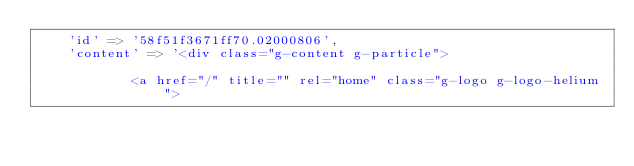<code> <loc_0><loc_0><loc_500><loc_500><_PHP_>    'id' => '58f51f3671ff70.02000806',
    'content' => '<div class="g-content g-particle">
                                                
            <a href="/" title="" rel="home" class="g-logo g-logo-helium"></code> 